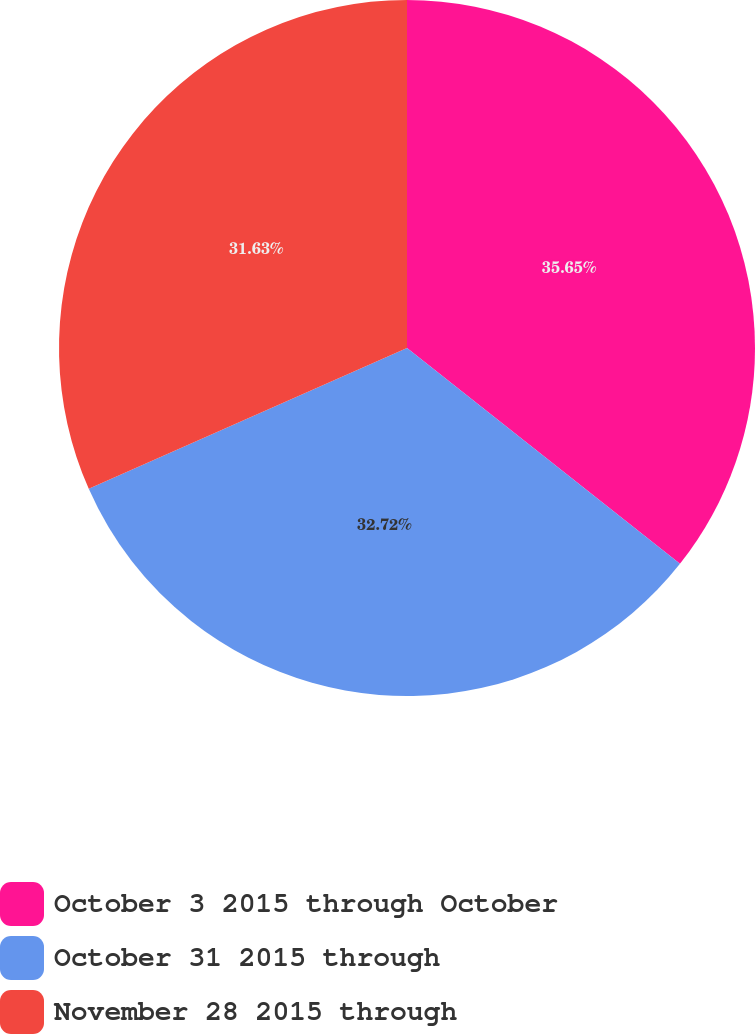Convert chart to OTSL. <chart><loc_0><loc_0><loc_500><loc_500><pie_chart><fcel>October 3 2015 through October<fcel>October 31 2015 through<fcel>November 28 2015 through<nl><fcel>35.65%<fcel>32.72%<fcel>31.63%<nl></chart> 